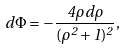<formula> <loc_0><loc_0><loc_500><loc_500>d \Phi = - \frac { 4 \rho d \rho } { ( \rho ^ { 2 } + 1 ) ^ { 2 } } ,</formula> 